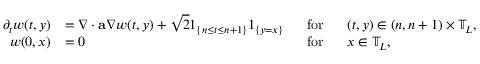<formula> <loc_0><loc_0><loc_500><loc_500>\begin{array} { r l r l } { \partial _ { t } w ( t , y ) } & { = \nabla \cdot a \nabla w ( t , y ) + \sqrt { 2 } { 1 } _ { \left \{ n \leq t \leq n + 1 \right \} } { 1 } _ { \{ y = x \} } } & { f o r } & { ( t , y ) \in ( n , n + 1 ) \times \mathbb { T } _ { L } , } \\ { w ( 0 , x ) } & { = 0 } & { f o r } & { x \in \mathbb { T } _ { L } , } \end{array}</formula> 